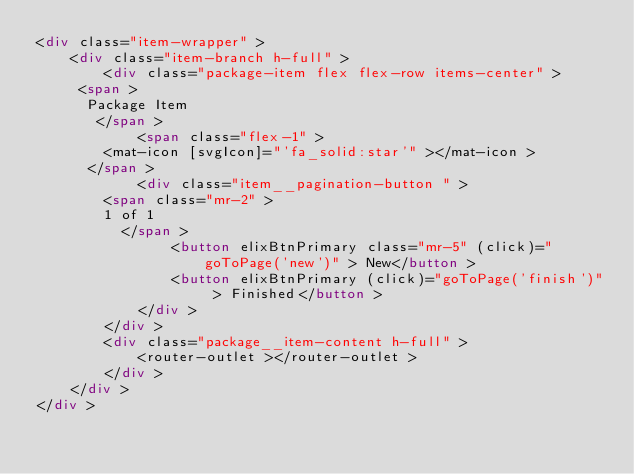Convert code to text. <code><loc_0><loc_0><loc_500><loc_500><_HTML_><div class="item-wrapper" >
	<div class="item-branch h-full" >
		<div class="package-item flex flex-row items-center" >
     <span >
      Package Item
       </span >
			<span class="flex-1" >
        <mat-icon [svgIcon]="'fa_solid:star'" ></mat-icon >
      </span >
			<div class="item__pagination-button " >
        <span class="mr-2" >
        1 of 1
          </span >
				<button elixBtnPrimary class="mr-5" (click)="goToPage('new')" > New</button >
				<button elixBtnPrimary (click)="goToPage('finish')" > Finished</button >
			</div >
		</div >
		<div class="package__item-content h-full" >
			<router-outlet ></router-outlet >
		</div >
	</div >
</div >
</code> 